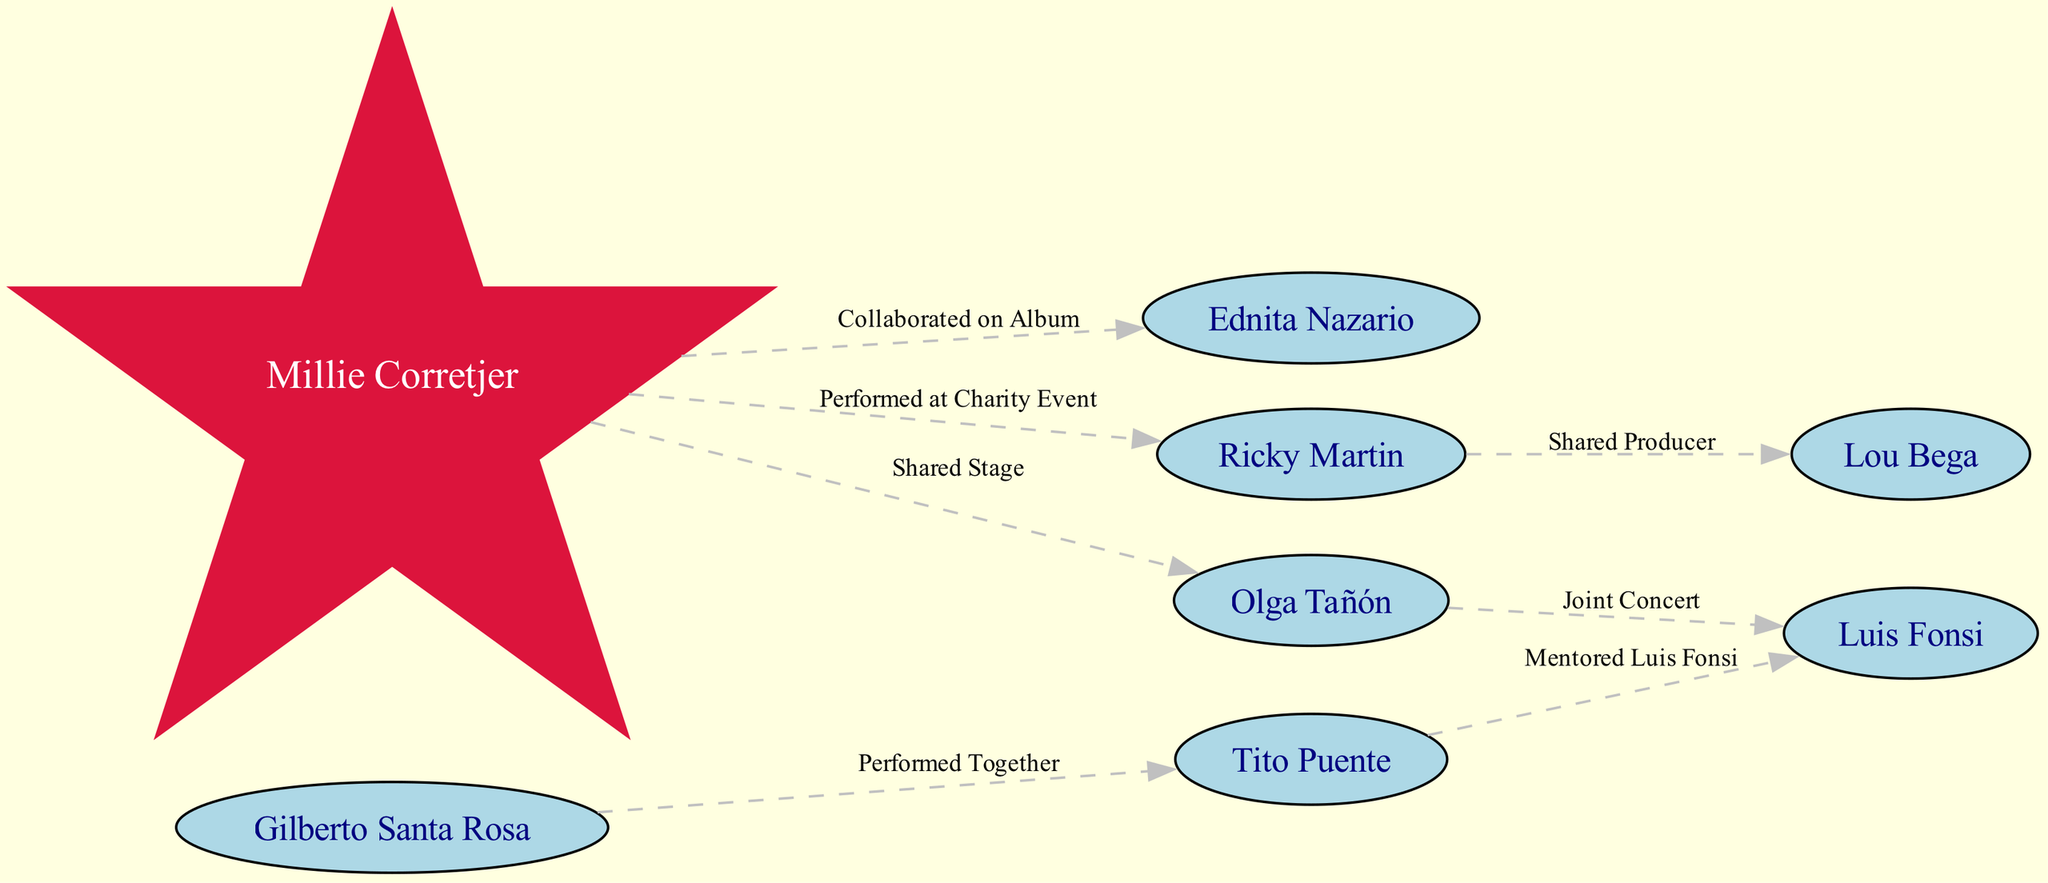What is the total number of artists in the network diagram? The diagram lists 8 unique nodes, each representing a different artist. By simply counting the nodes, we see there are 8 artists.
Answer: 8 Who did Millie Corretjer collaborate with on an album? The edge labeled "Collaborated on Album" connects Millie Corretjer to Ednita Nazario. This indicates that their relationship is specifically a collaboration on an album.
Answer: Ednita Nazario How many total collaborations does Ricky Martin have in the diagram? Ricky Martin is connected to two other artists, Millie Corretjer (for a charity event) and Lou Bega (as shared producer). Thus, he has 2 collaborations indicated in the diagram.
Answer: 2 Which artist is shown to have performed a duet with Millie Corretjer? The edge labeled "Duet Performance" connects Millie Corretjer to Gilberto Santa Rosa, indicating that they performed a duet together.
Answer: Gilberto Santa Rosa Who mentored Luis Fonsi according to the diagram? The edge labeled "Mentored Luis Fonsi" connects Tito Puente to Luis Fonsi, revealing that Tito Puente is the one who mentored him.
Answer: Tito Puente What type of event did Millie Corretjer and Ricky Martin perform at together? The edge notation "Performed at Charity Event" specifies the event type that connects Millie Corretjer and Ricky Martin.
Answer: Charity Event Which artist shares a stage with Millie Corretjer? The edge labeled "Shared Stage" shows a connection between Millie Corretjer and Olga Tañón, indicating they have shared a stage.
Answer: Olga Tañón How many connections involve Luis Fonsi as either a collaborator or a mentee? Luis Fonsi has two connections: he is mentored by Tito Puente and has a joint concert with Olga Tañón, totaling 2 collaborative relationships in the diagram.
Answer: 2 What was the relationship between Gilberto Santa Rosa and Tito Puente? The edge labeled "Performed Together" indicates that Gilberto Santa Rosa and Tito Puente have performed together, outlining their collaborative relationship.
Answer: Performed Together 